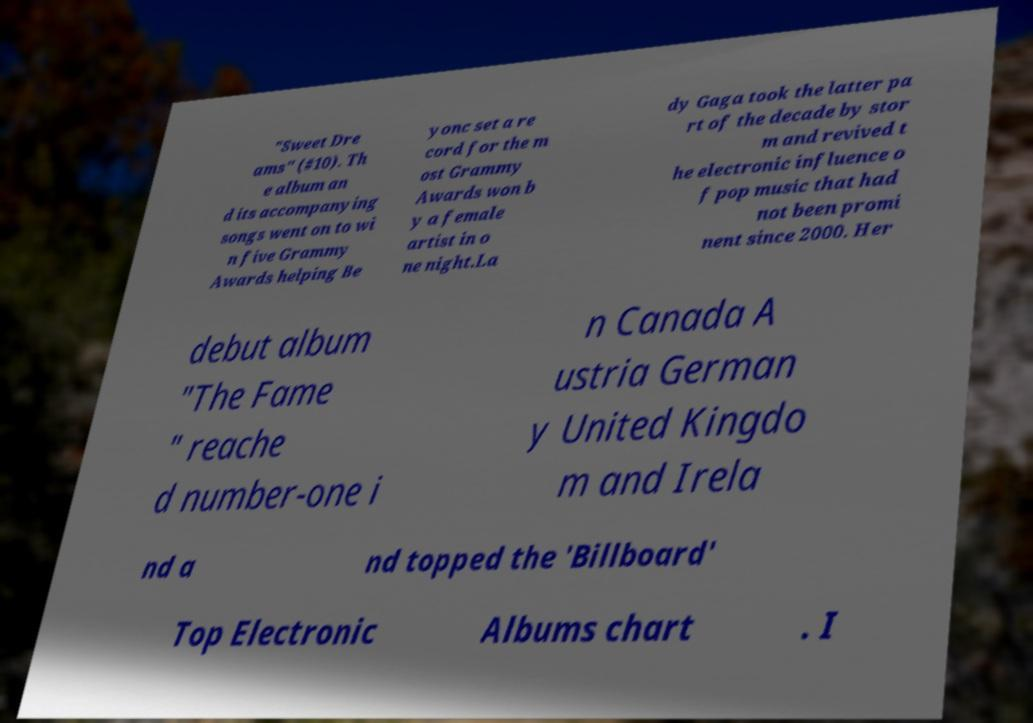Could you assist in decoding the text presented in this image and type it out clearly? "Sweet Dre ams" (#10). Th e album an d its accompanying songs went on to wi n five Grammy Awards helping Be yonc set a re cord for the m ost Grammy Awards won b y a female artist in o ne night.La dy Gaga took the latter pa rt of the decade by stor m and revived t he electronic influence o f pop music that had not been promi nent since 2000. Her debut album "The Fame " reache d number-one i n Canada A ustria German y United Kingdo m and Irela nd a nd topped the 'Billboard' Top Electronic Albums chart . I 